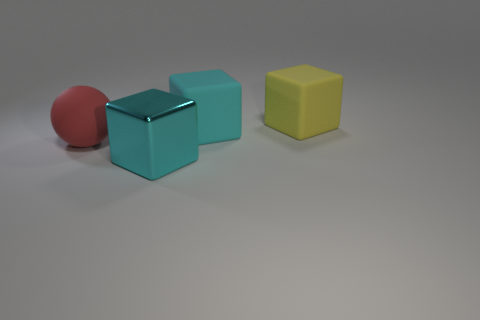There is a large matte block left of the object that is behind the large rubber block in front of the large yellow matte object; what color is it?
Your answer should be very brief. Cyan. How many gray things are tiny matte cubes or matte cubes?
Make the answer very short. 0. How many small cyan rubber blocks are there?
Offer a terse response. 0. Is there any other thing that is the same shape as the cyan metal thing?
Provide a short and direct response. Yes. Does the block in front of the rubber sphere have the same material as the cyan cube behind the red rubber thing?
Make the answer very short. No. What is the yellow block made of?
Provide a succinct answer. Rubber. What number of big yellow objects have the same material as the red ball?
Ensure brevity in your answer.  1. How many metallic objects are large balls or big green things?
Your answer should be compact. 0. There is a cyan thing in front of the big red thing; does it have the same shape as the large yellow rubber thing behind the red rubber thing?
Offer a terse response. Yes. There is a matte object that is behind the sphere and on the left side of the big yellow cube; what color is it?
Your answer should be compact. Cyan. 